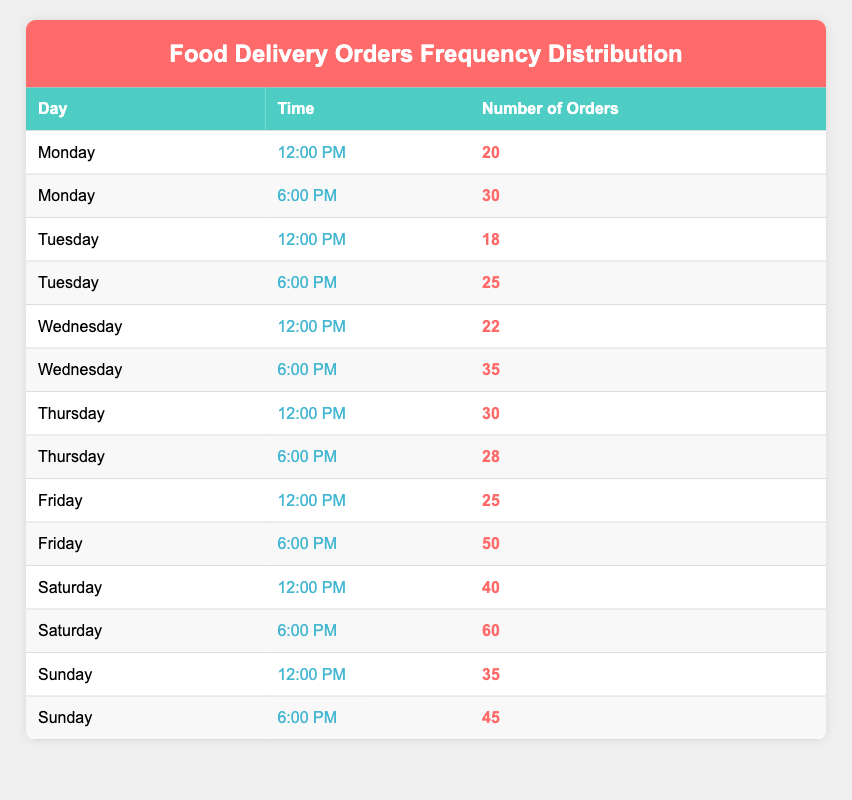What is the total number of food delivery orders on Saturday? To find the total number of food delivery orders on Saturday, we look at the orders for both time slots. For Saturday, at 12:00 PM, there are 40 orders, and at 6:00 PM, there are 60 orders. We add these two amounts together: 40 + 60 = 100.
Answer: 100 Which day had the most food delivery orders at 6:00 PM? We check each day’s orders for 6:00 PM. The numbers are as follows: Monday has 30, Tuesday has 25, Wednesday has 35, Thursday has 28, Friday has 50, Saturday has 60, and Sunday has 45. The highest number is on Saturday with 60 orders.
Answer: Saturday Is there a day when the number of orders at 12:00 PM is greater than at 6:00 PM? We compare the number of orders for each day at both time slots. The orders for 12:00 PM are: Monday 20, Tuesday 18, Wednesday 22, Thursday 30, Friday 25, Saturday 40, and Sunday 35. The orders at 6:00 PM are: Monday 30, Tuesday 25, Wednesday 35, Thursday 28, Friday 50, Saturday 60, and Sunday 45. None of the 12:00 PM orders exceed their respective 6:00 PM orders. Therefore, the answer is no.
Answer: No What is the average number of food delivery orders across all days at 6:00 PM? To find the average number of orders at 6:00 PM, we first sum all the 6:00 PM order values: 30 (Monday) + 25 (Tuesday) + 35 (Wednesday) + 28 (Thursday) + 50 (Friday) + 60 (Saturday) + 45 (Sunday) = 273. There are 7 days, so we divide the total by 7: 273 / 7 = approximately 39. Therefore, the average is about 39.
Answer: 39 Are there more orders at 12:00 PM than at 6:00 PM on Friday? On Friday, the number of orders at 12:00 PM is 25, and at 6:00 PM it is 50. Comparing these, 25 is less than 50, so there are not more orders at 12:00 PM.
Answer: No 